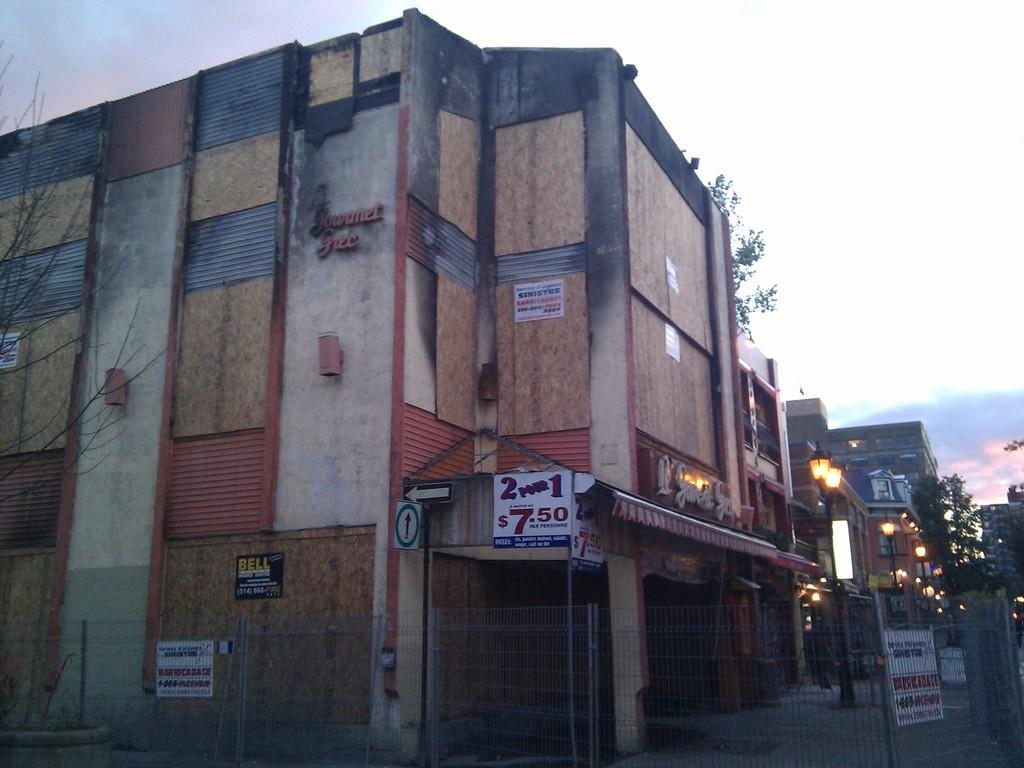What type of barrier can be seen in the image? There is a metal fence in the image. What structures are present in the image? There are buildings in the image. What type of vegetation is visible in the image? There are trees in the image. What type of illumination is present in the image? There are lights in the image. What can be seen in the background of the image? The sky is visible in the background of the image. What type of poison is being used to water the trees in the image? There is no mention of poison or any indication that the trees are being watered in the image. 